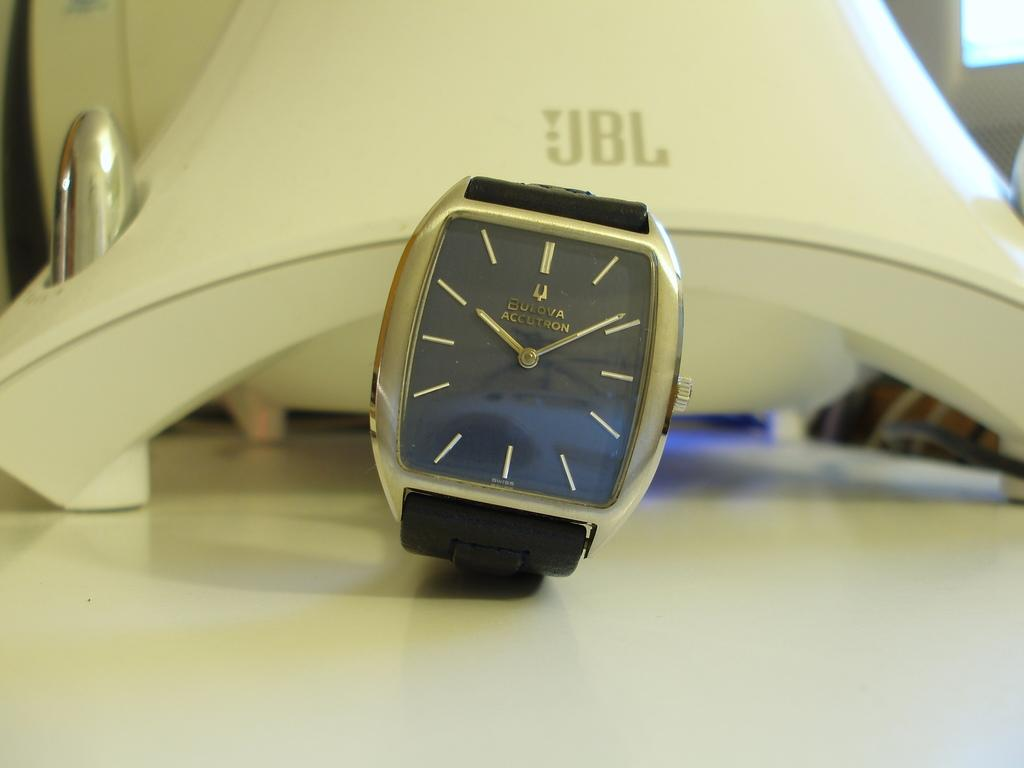<image>
Give a short and clear explanation of the subsequent image. A Bulova Accuton watch is sitting on a table. 